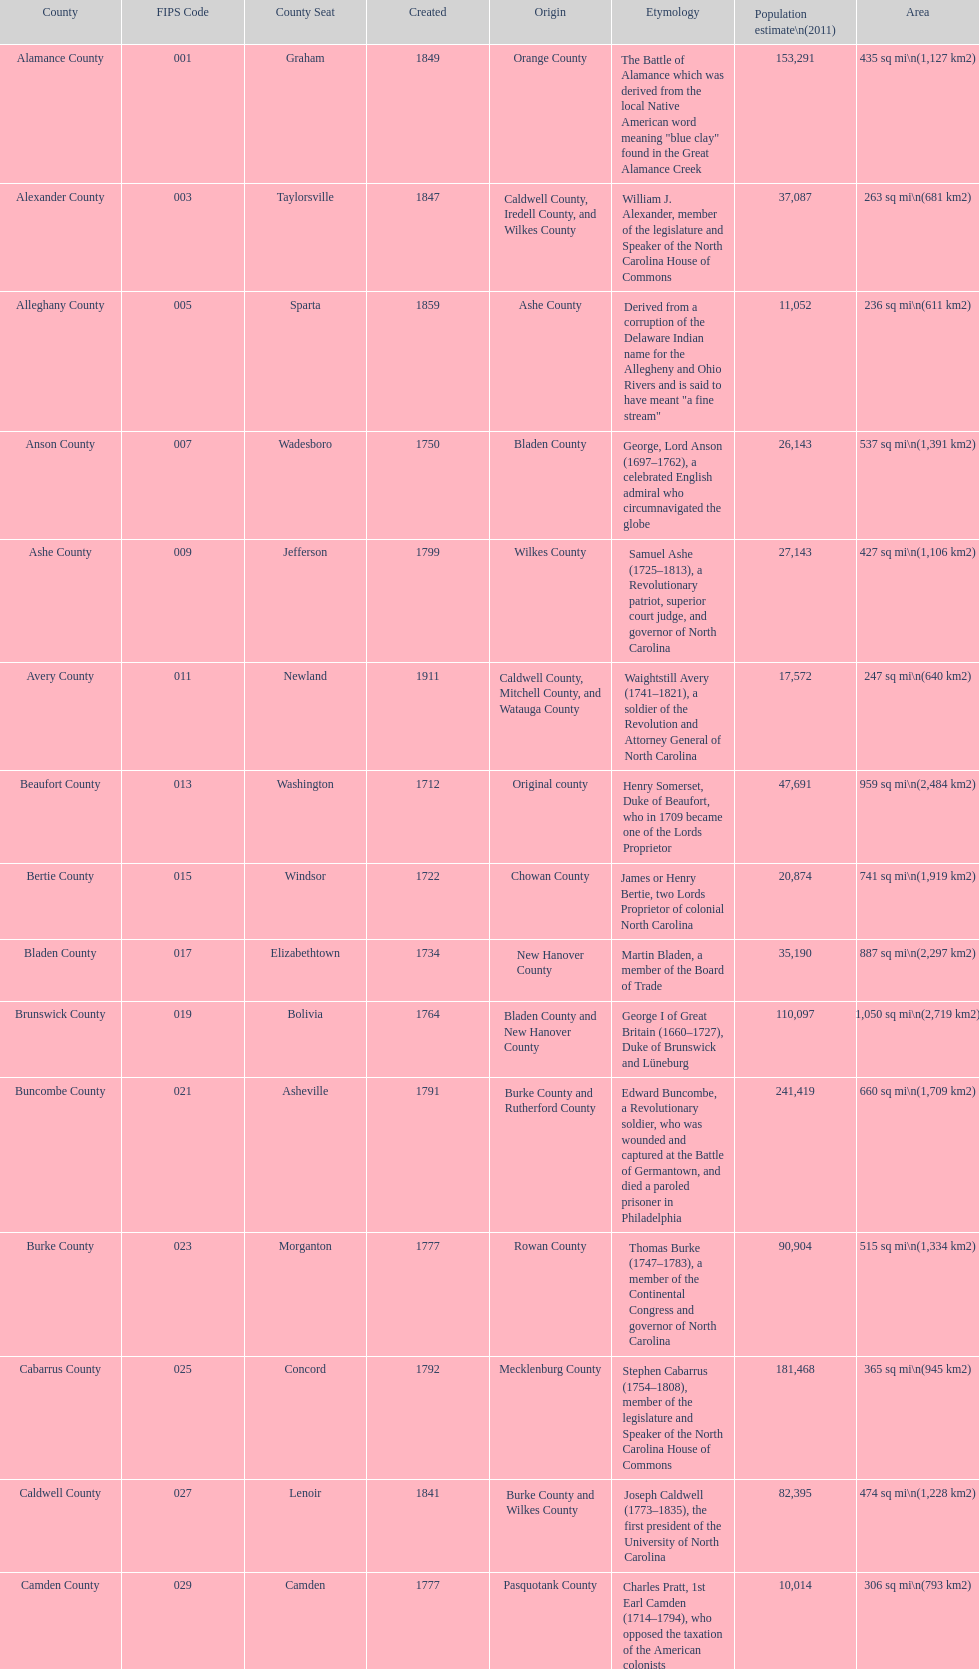What is the only county whose name comes from a battle? Alamance County. 